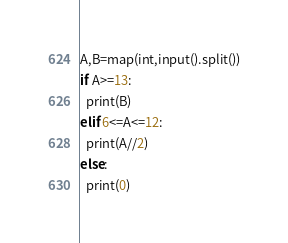Convert code to text. <code><loc_0><loc_0><loc_500><loc_500><_Python_>A,B=map(int,input().split())
if A>=13:
  print(B)
elif 6<=A<=12:
  print(A//2)
else:
  print(0)</code> 